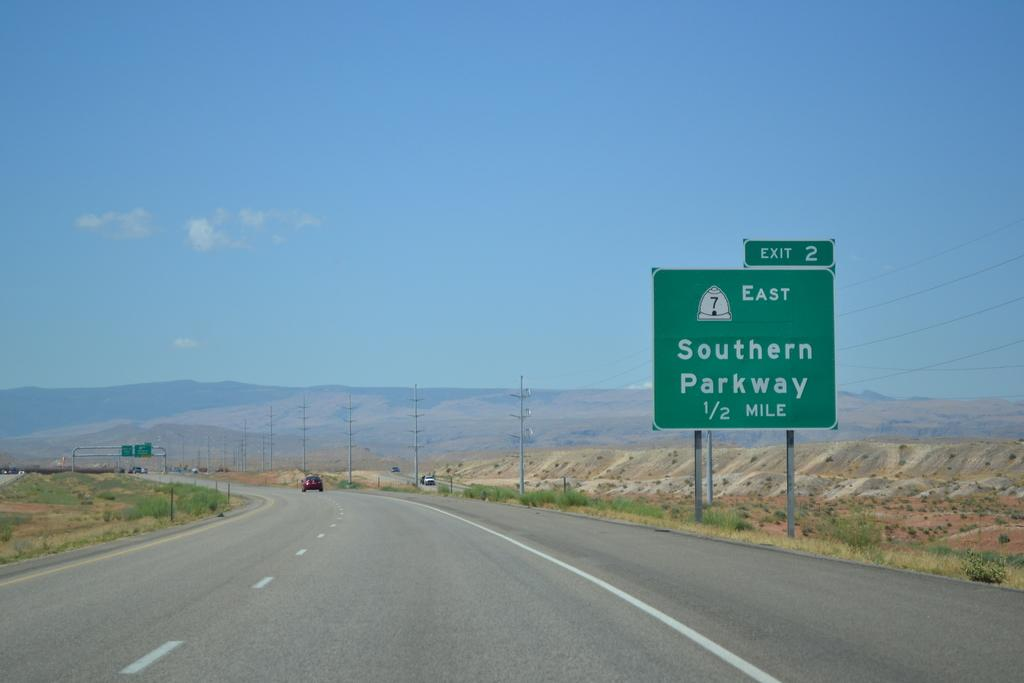<image>
Write a terse but informative summary of the picture. A green highway sign indicates Exit 2 and the Southern Parkway. 